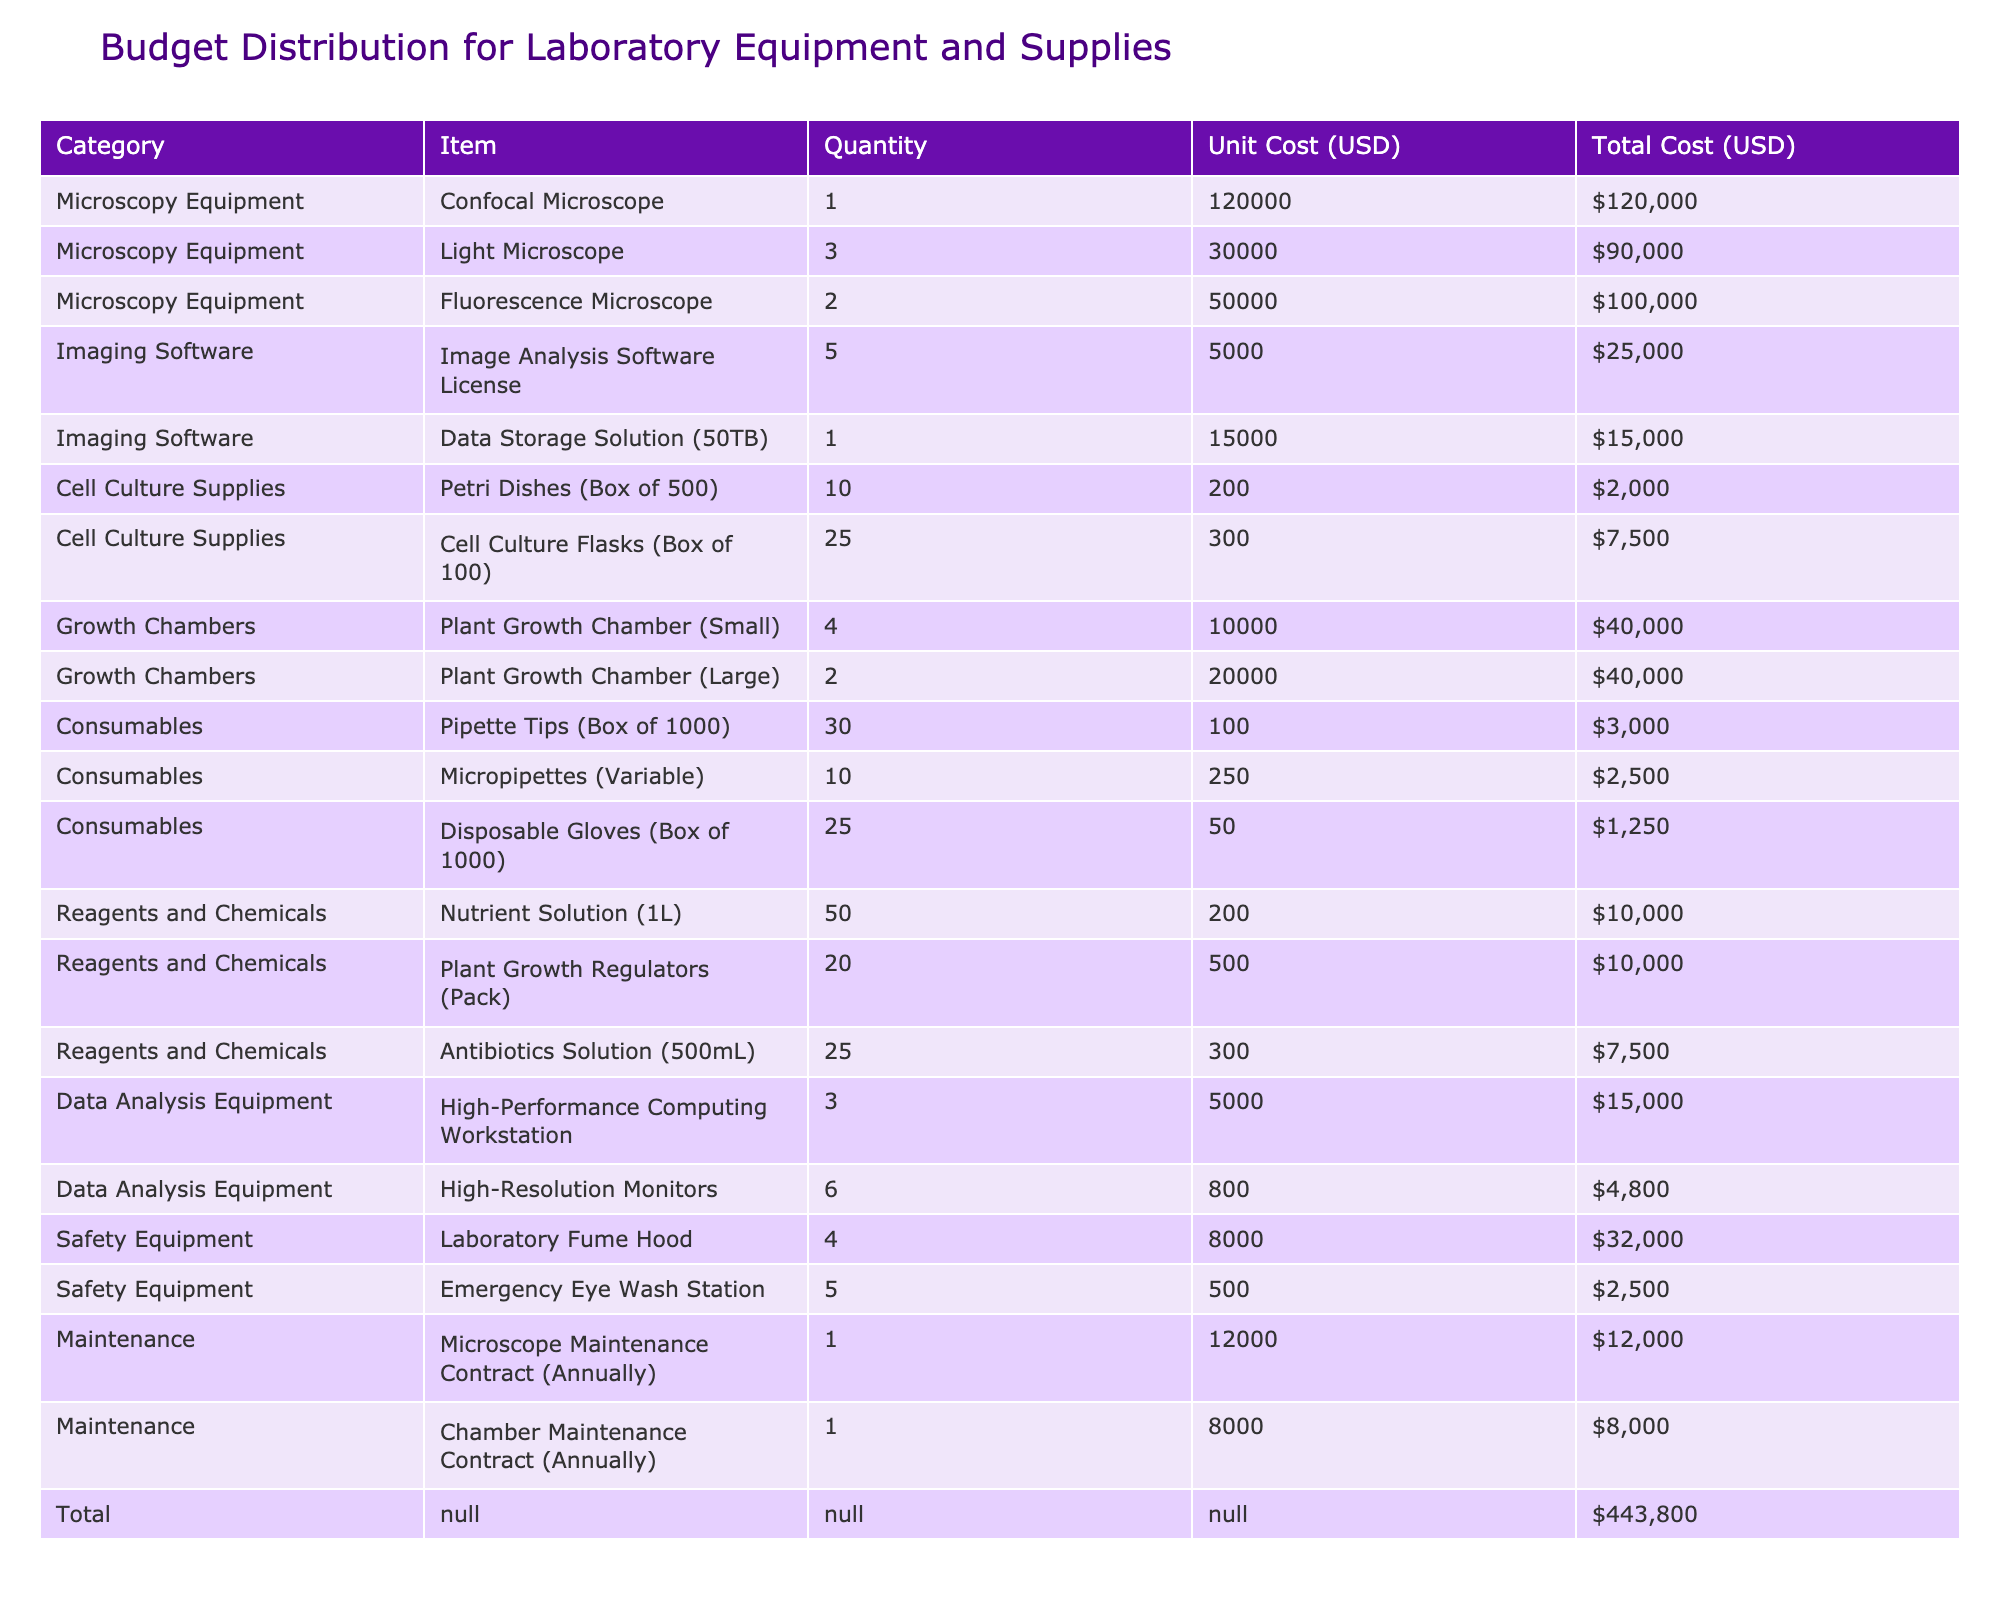What is the total cost for microscopy equipment? To find the total cost for microscopy equipment, we need to sum the total costs of all items in that category. The items are: Confocal Microscope ($120,000), Light Microscope ($90,000), and Fluorescence Microscope ($100,000). So, total cost = 120000 + 90000 + 100000 = 310000.
Answer: 310000 How many items are in the category of safety equipment? The safety equipment category contains two items: Laboratory Fume Hood and Emergency Eye Wash Station. Therefore, the number of items is 2.
Answer: 2 Is the total cost for maintenance more than the total cost for cell culture supplies? The total cost for maintenance is $20,000 ($12,000 for microscope maintenance and $8,000 for chamber maintenance). The total cost for cell culture supplies is $9,500 ($2,000 for Petri Dishes and $7,500 for Cell Culture Flasks). Since 20,000 > 9,500, the statement is true.
Answer: Yes What is the percentage of the total budget allocated to imaging software? The total cost for imaging software is $40,000 ($25,000 for Image Analysis Software and $15,000 for Data Storage Solution). The total budget is $443,800. To find the percentage, we calculate (40,000 / 443,800) * 100 = 9.01%.
Answer: 9.01% Which category has the highest total cost? By examining the total costs in each category, we find that Microscopy Equipment has the highest total cost of $310,000, which is more than any other category in the table.
Answer: Microscopy Equipment 